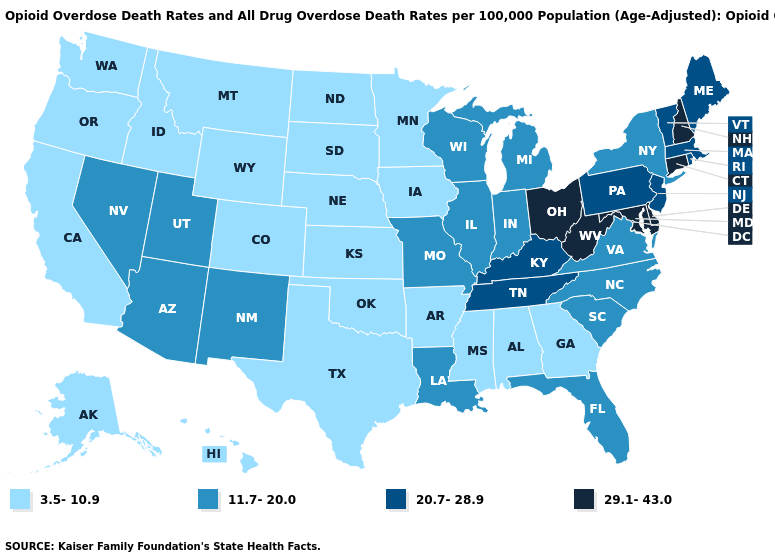What is the highest value in the USA?
Be succinct. 29.1-43.0. How many symbols are there in the legend?
Write a very short answer. 4. What is the value of Connecticut?
Give a very brief answer. 29.1-43.0. Is the legend a continuous bar?
Answer briefly. No. Which states have the highest value in the USA?
Write a very short answer. Connecticut, Delaware, Maryland, New Hampshire, Ohio, West Virginia. Does Wyoming have the highest value in the USA?
Concise answer only. No. Is the legend a continuous bar?
Keep it brief. No. Does New Jersey have the lowest value in the Northeast?
Quick response, please. No. Among the states that border Arkansas , does Tennessee have the highest value?
Quick response, please. Yes. What is the value of Idaho?
Keep it brief. 3.5-10.9. What is the lowest value in states that border Maryland?
Short answer required. 11.7-20.0. Does Missouri have the same value as New York?
Concise answer only. Yes. Among the states that border Illinois , which have the lowest value?
Short answer required. Iowa. What is the highest value in states that border Connecticut?
Write a very short answer. 20.7-28.9. Which states have the highest value in the USA?
Give a very brief answer. Connecticut, Delaware, Maryland, New Hampshire, Ohio, West Virginia. 